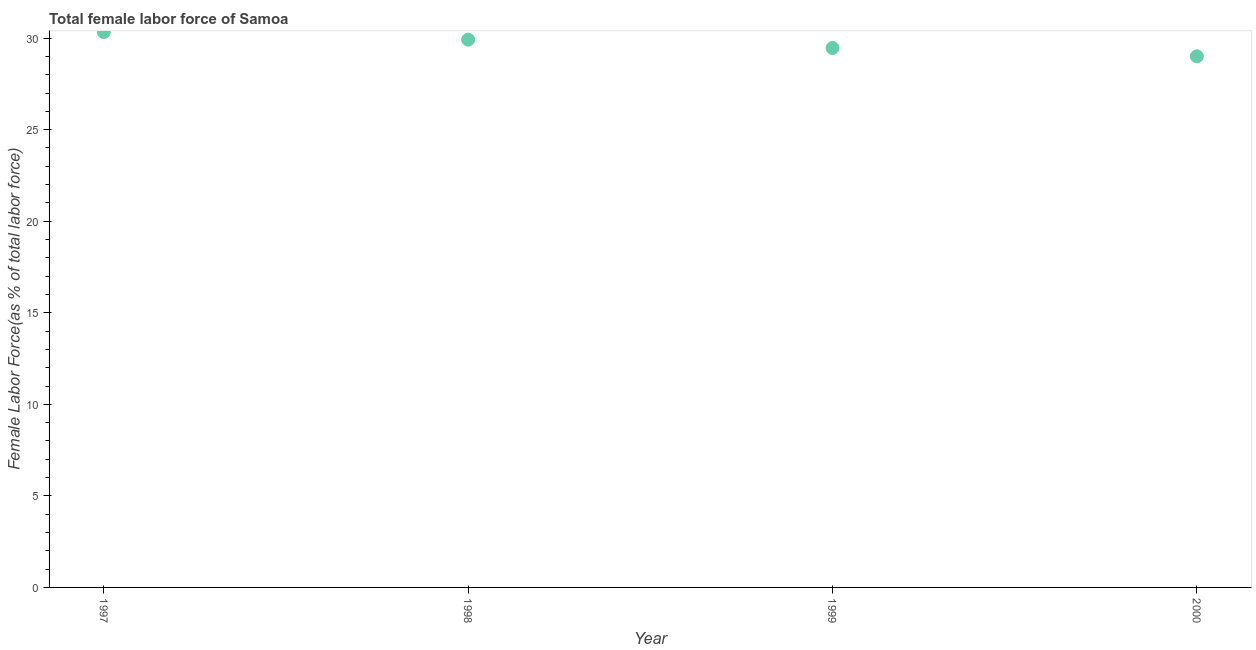What is the total female labor force in 1999?
Make the answer very short. 29.46. Across all years, what is the maximum total female labor force?
Your response must be concise. 30.33. Across all years, what is the minimum total female labor force?
Your answer should be compact. 29. In which year was the total female labor force maximum?
Your response must be concise. 1997. What is the sum of the total female labor force?
Provide a succinct answer. 118.71. What is the difference between the total female labor force in 1997 and 1998?
Your answer should be compact. 0.41. What is the average total female labor force per year?
Your response must be concise. 29.68. What is the median total female labor force?
Provide a short and direct response. 29.69. What is the ratio of the total female labor force in 1997 to that in 1999?
Provide a succinct answer. 1.03. What is the difference between the highest and the second highest total female labor force?
Your answer should be very brief. 0.41. Is the sum of the total female labor force in 1998 and 1999 greater than the maximum total female labor force across all years?
Your response must be concise. Yes. What is the difference between the highest and the lowest total female labor force?
Give a very brief answer. 1.33. Does the total female labor force monotonically increase over the years?
Make the answer very short. No. How many dotlines are there?
Your answer should be very brief. 1. How many years are there in the graph?
Offer a terse response. 4. Are the values on the major ticks of Y-axis written in scientific E-notation?
Provide a short and direct response. No. Does the graph contain any zero values?
Offer a terse response. No. What is the title of the graph?
Your answer should be compact. Total female labor force of Samoa. What is the label or title of the Y-axis?
Ensure brevity in your answer.  Female Labor Force(as % of total labor force). What is the Female Labor Force(as % of total labor force) in 1997?
Offer a very short reply. 30.33. What is the Female Labor Force(as % of total labor force) in 1998?
Provide a succinct answer. 29.92. What is the Female Labor Force(as % of total labor force) in 1999?
Offer a very short reply. 29.46. What is the Female Labor Force(as % of total labor force) in 2000?
Offer a terse response. 29. What is the difference between the Female Labor Force(as % of total labor force) in 1997 and 1998?
Give a very brief answer. 0.41. What is the difference between the Female Labor Force(as % of total labor force) in 1997 and 1999?
Make the answer very short. 0.87. What is the difference between the Female Labor Force(as % of total labor force) in 1997 and 2000?
Your answer should be very brief. 1.33. What is the difference between the Female Labor Force(as % of total labor force) in 1998 and 1999?
Make the answer very short. 0.46. What is the difference between the Female Labor Force(as % of total labor force) in 1998 and 2000?
Offer a very short reply. 0.91. What is the difference between the Female Labor Force(as % of total labor force) in 1999 and 2000?
Offer a very short reply. 0.45. What is the ratio of the Female Labor Force(as % of total labor force) in 1997 to that in 1998?
Make the answer very short. 1.01. What is the ratio of the Female Labor Force(as % of total labor force) in 1997 to that in 1999?
Provide a short and direct response. 1.03. What is the ratio of the Female Labor Force(as % of total labor force) in 1997 to that in 2000?
Provide a short and direct response. 1.05. What is the ratio of the Female Labor Force(as % of total labor force) in 1998 to that in 2000?
Keep it short and to the point. 1.03. 